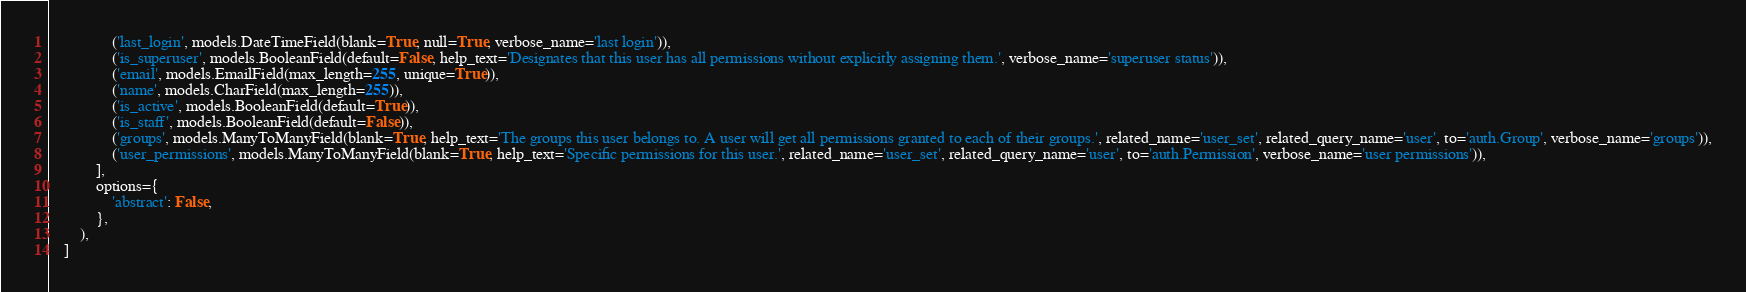<code> <loc_0><loc_0><loc_500><loc_500><_Python_>                ('last_login', models.DateTimeField(blank=True, null=True, verbose_name='last login')),
                ('is_superuser', models.BooleanField(default=False, help_text='Designates that this user has all permissions without explicitly assigning them.', verbose_name='superuser status')),
                ('email', models.EmailField(max_length=255, unique=True)),
                ('name', models.CharField(max_length=255)),
                ('is_active', models.BooleanField(default=True)),
                ('is_staff', models.BooleanField(default=False)),
                ('groups', models.ManyToManyField(blank=True, help_text='The groups this user belongs to. A user will get all permissions granted to each of their groups.', related_name='user_set', related_query_name='user', to='auth.Group', verbose_name='groups')),
                ('user_permissions', models.ManyToManyField(blank=True, help_text='Specific permissions for this user.', related_name='user_set', related_query_name='user', to='auth.Permission', verbose_name='user permissions')),
            ],
            options={
                'abstract': False,
            },
        ),
    ]
</code> 